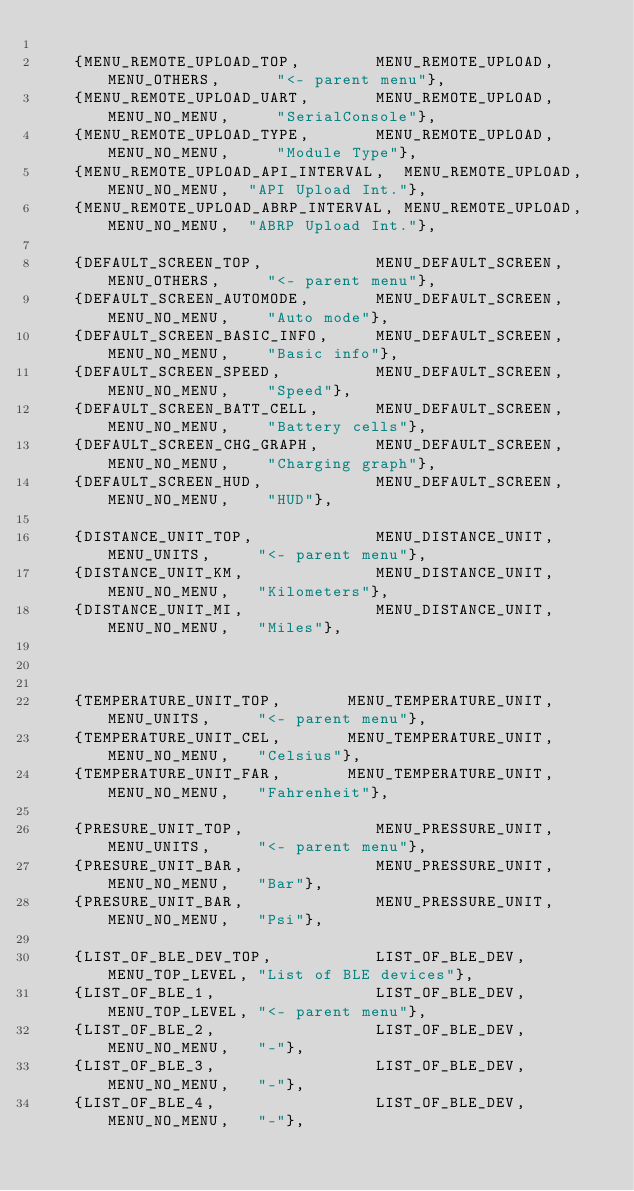Convert code to text. <code><loc_0><loc_0><loc_500><loc_500><_C_>
    {MENU_REMOTE_UPLOAD_TOP,        MENU_REMOTE_UPLOAD, MENU_OTHERS,      "<- parent menu"},
    {MENU_REMOTE_UPLOAD_UART,       MENU_REMOTE_UPLOAD, MENU_NO_MENU,     "SerialConsole"},
    {MENU_REMOTE_UPLOAD_TYPE,       MENU_REMOTE_UPLOAD, MENU_NO_MENU,     "Module Type"},
    {MENU_REMOTE_UPLOAD_API_INTERVAL,  MENU_REMOTE_UPLOAD, MENU_NO_MENU,  "API Upload Int."},
    {MENU_REMOTE_UPLOAD_ABRP_INTERVAL, MENU_REMOTE_UPLOAD, MENU_NO_MENU,  "ABRP Upload Int."},

    {DEFAULT_SCREEN_TOP,            MENU_DEFAULT_SCREEN, MENU_OTHERS,     "<- parent menu"},
    {DEFAULT_SCREEN_AUTOMODE,       MENU_DEFAULT_SCREEN, MENU_NO_MENU,    "Auto mode"},
    {DEFAULT_SCREEN_BASIC_INFO,     MENU_DEFAULT_SCREEN, MENU_NO_MENU,    "Basic info"},
    {DEFAULT_SCREEN_SPEED,          MENU_DEFAULT_SCREEN, MENU_NO_MENU,    "Speed"},
    {DEFAULT_SCREEN_BATT_CELL,      MENU_DEFAULT_SCREEN, MENU_NO_MENU,    "Battery cells"},
    {DEFAULT_SCREEN_CHG_GRAPH,      MENU_DEFAULT_SCREEN, MENU_NO_MENU,    "Charging graph"},
    {DEFAULT_SCREEN_HUD,            MENU_DEFAULT_SCREEN, MENU_NO_MENU,    "HUD"},

    {DISTANCE_UNIT_TOP,             MENU_DISTANCE_UNIT,  MENU_UNITS,     "<- parent menu"},
    {DISTANCE_UNIT_KM,              MENU_DISTANCE_UNIT,  MENU_NO_MENU,   "Kilometers"},
    {DISTANCE_UNIT_MI,              MENU_DISTANCE_UNIT,  MENU_NO_MENU,   "Miles"},



    {TEMPERATURE_UNIT_TOP,       MENU_TEMPERATURE_UNIT,  MENU_UNITS,     "<- parent menu"},
    {TEMPERATURE_UNIT_CEL,       MENU_TEMPERATURE_UNIT,  MENU_NO_MENU,   "Celsius"},
    {TEMPERATURE_UNIT_FAR,       MENU_TEMPERATURE_UNIT,  MENU_NO_MENU,   "Fahrenheit"},

    {PRESURE_UNIT_TOP,              MENU_PRESSURE_UNIT,  MENU_UNITS,     "<- parent menu"},
    {PRESURE_UNIT_BAR,              MENU_PRESSURE_UNIT,  MENU_NO_MENU,   "Bar"},
    {PRESURE_UNIT_BAR,              MENU_PRESSURE_UNIT,  MENU_NO_MENU,   "Psi"},

    {LIST_OF_BLE_DEV_TOP,           LIST_OF_BLE_DEV,     MENU_TOP_LEVEL, "List of BLE devices"},
    {LIST_OF_BLE_1,                 LIST_OF_BLE_DEV,     MENU_TOP_LEVEL, "<- parent menu"},
    {LIST_OF_BLE_2,                 LIST_OF_BLE_DEV,     MENU_NO_MENU,   "-"},
    {LIST_OF_BLE_3,                 LIST_OF_BLE_DEV,     MENU_NO_MENU,   "-"},
    {LIST_OF_BLE_4,                 LIST_OF_BLE_DEV,     MENU_NO_MENU,   "-"},</code> 